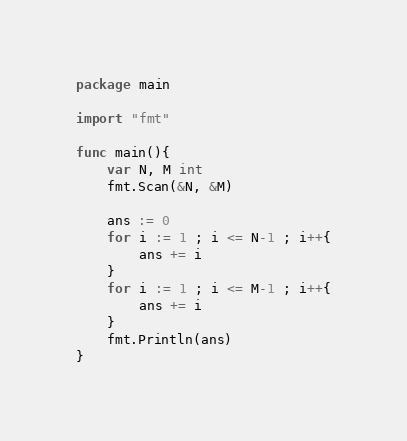<code> <loc_0><loc_0><loc_500><loc_500><_Go_>package main

import "fmt"

func main(){
	var N, M int
	fmt.Scan(&N, &M)

	ans := 0
	for i := 1 ; i <= N-1 ; i++{
		ans += i
	}
	for i := 1 ; i <= M-1 ; i++{
		ans += i
	}
	fmt.Println(ans)
}</code> 